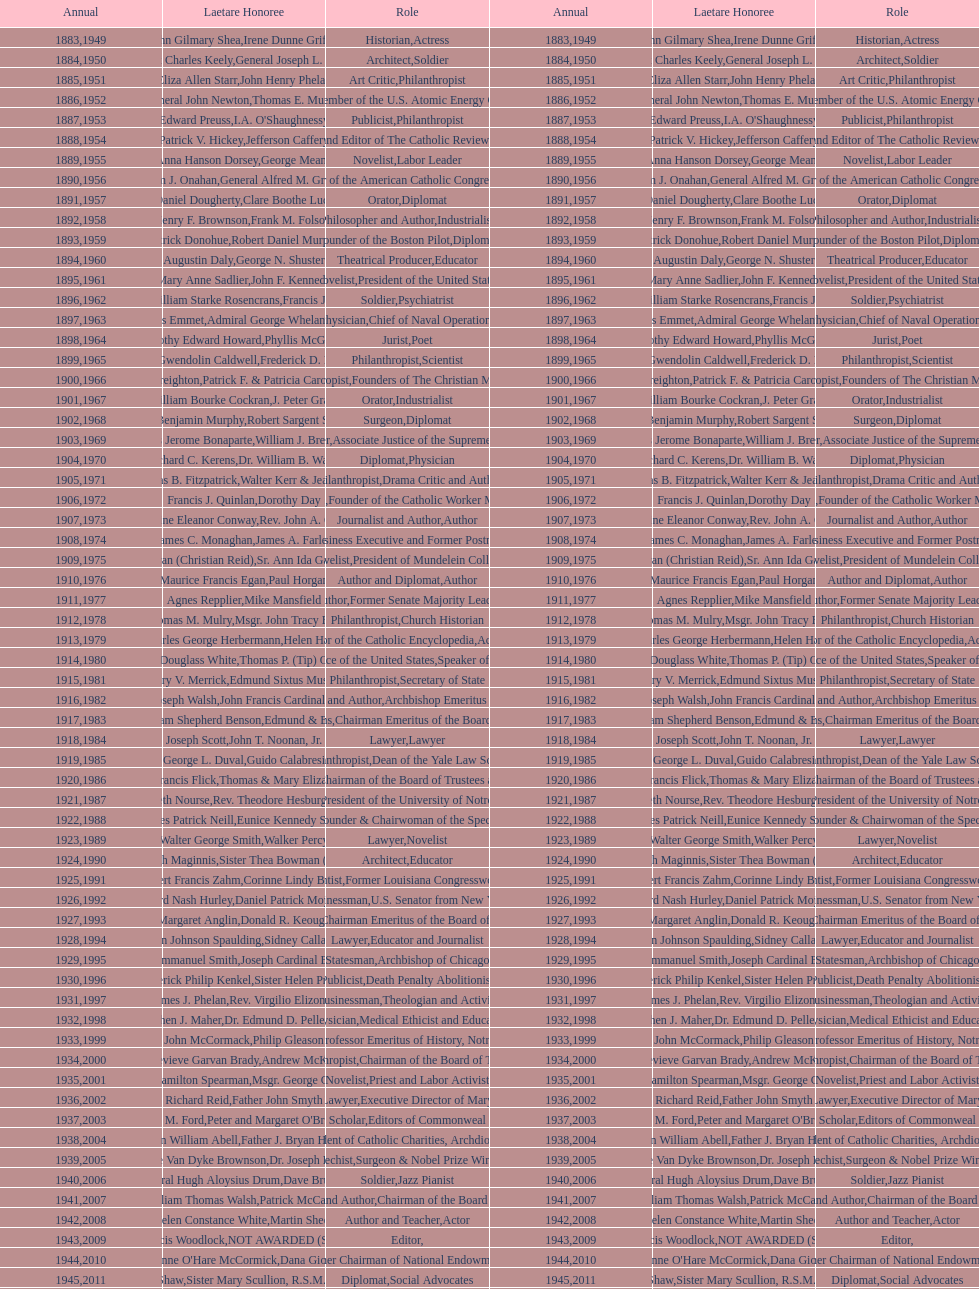How many laetare medalists were philantrohpists? 2. 